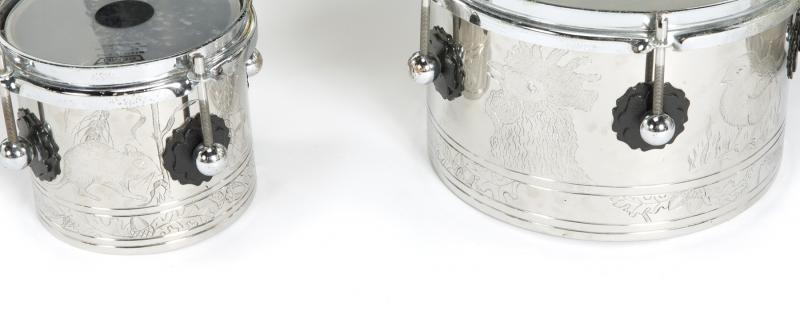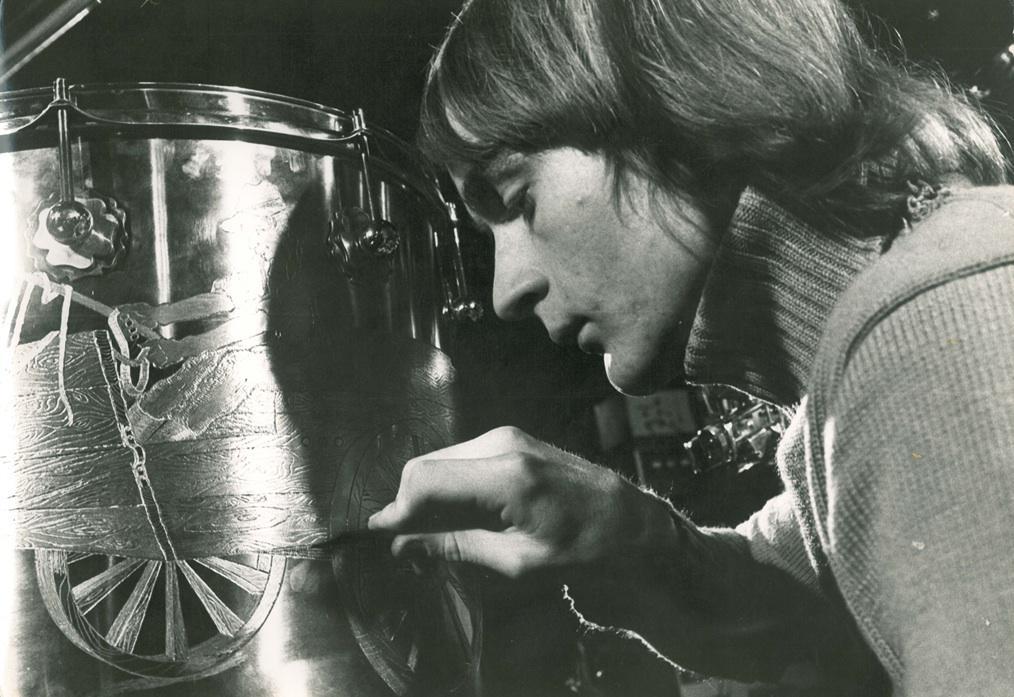The first image is the image on the left, the second image is the image on the right. Assess this claim about the two images: "The image to the left is a color image (not black & white) and features steel drums.". Correct or not? Answer yes or no. No. The first image is the image on the left, the second image is the image on the right. Considering the images on both sides, is "There is a man in one image, but not the other." valid? Answer yes or no. Yes. 